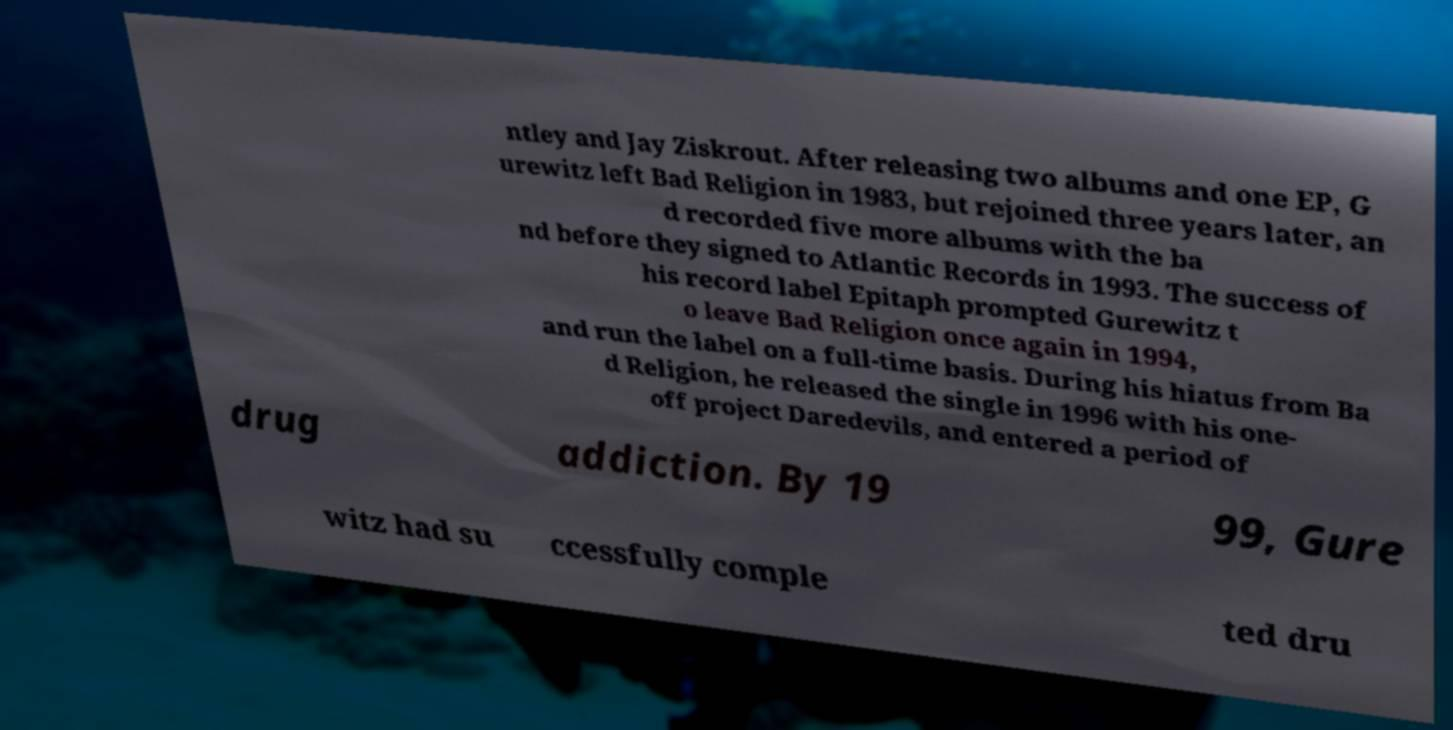For documentation purposes, I need the text within this image transcribed. Could you provide that? ntley and Jay Ziskrout. After releasing two albums and one EP, G urewitz left Bad Religion in 1983, but rejoined three years later, an d recorded five more albums with the ba nd before they signed to Atlantic Records in 1993. The success of his record label Epitaph prompted Gurewitz t o leave Bad Religion once again in 1994, and run the label on a full-time basis. During his hiatus from Ba d Religion, he released the single in 1996 with his one- off project Daredevils, and entered a period of drug addiction. By 19 99, Gure witz had su ccessfully comple ted dru 